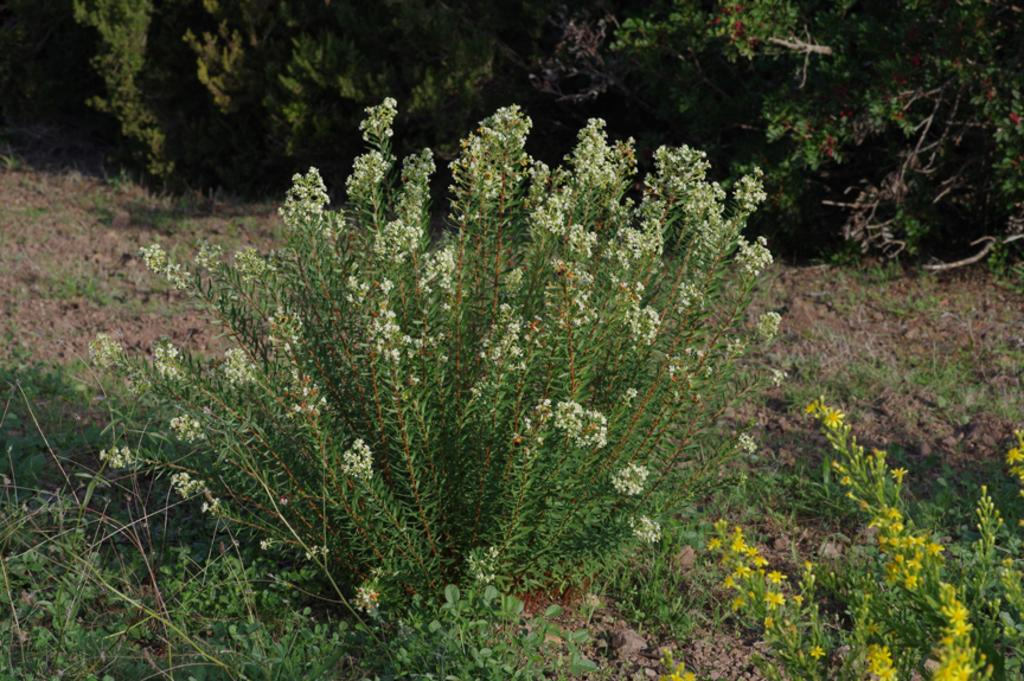What type of living organisms can be seen in the image? Plants can be seen in the image. What historical events can be seen taking place in the image? There are no historical events depicted in the image, as it only features plants. How many leaves can be seen on the plants in the image? The number of leaves on the plants cannot be determined from the image alone, as it only shows the plants in general. 